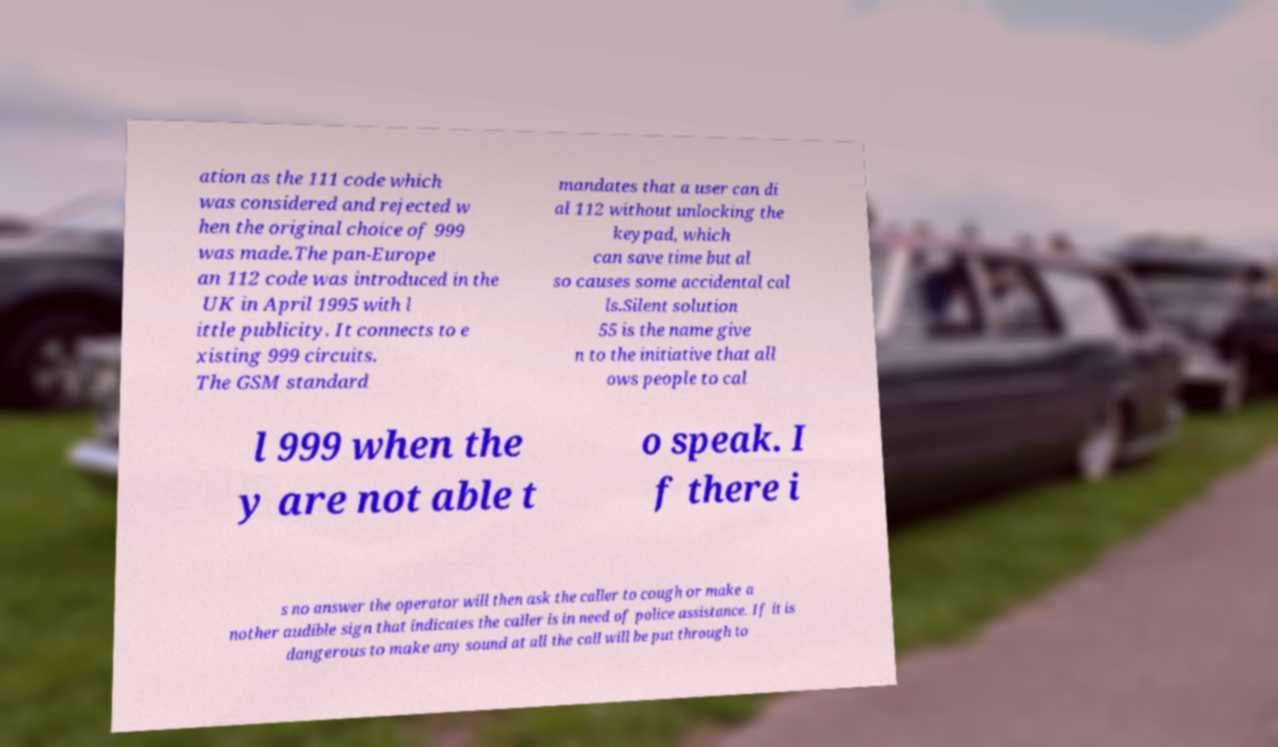For documentation purposes, I need the text within this image transcribed. Could you provide that? ation as the 111 code which was considered and rejected w hen the original choice of 999 was made.The pan-Europe an 112 code was introduced in the UK in April 1995 with l ittle publicity. It connects to e xisting 999 circuits. The GSM standard mandates that a user can di al 112 without unlocking the keypad, which can save time but al so causes some accidental cal ls.Silent solution 55 is the name give n to the initiative that all ows people to cal l 999 when the y are not able t o speak. I f there i s no answer the operator will then ask the caller to cough or make a nother audible sign that indicates the caller is in need of police assistance. If it is dangerous to make any sound at all the call will be put through to 